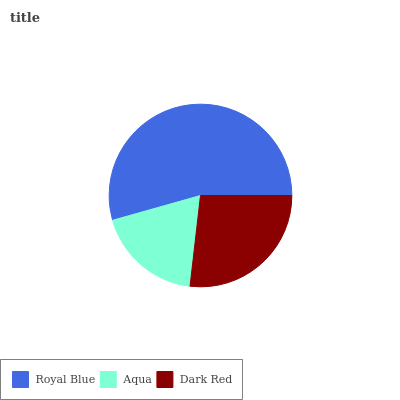Is Aqua the minimum?
Answer yes or no. Yes. Is Royal Blue the maximum?
Answer yes or no. Yes. Is Dark Red the minimum?
Answer yes or no. No. Is Dark Red the maximum?
Answer yes or no. No. Is Dark Red greater than Aqua?
Answer yes or no. Yes. Is Aqua less than Dark Red?
Answer yes or no. Yes. Is Aqua greater than Dark Red?
Answer yes or no. No. Is Dark Red less than Aqua?
Answer yes or no. No. Is Dark Red the high median?
Answer yes or no. Yes. Is Dark Red the low median?
Answer yes or no. Yes. Is Aqua the high median?
Answer yes or no. No. Is Aqua the low median?
Answer yes or no. No. 